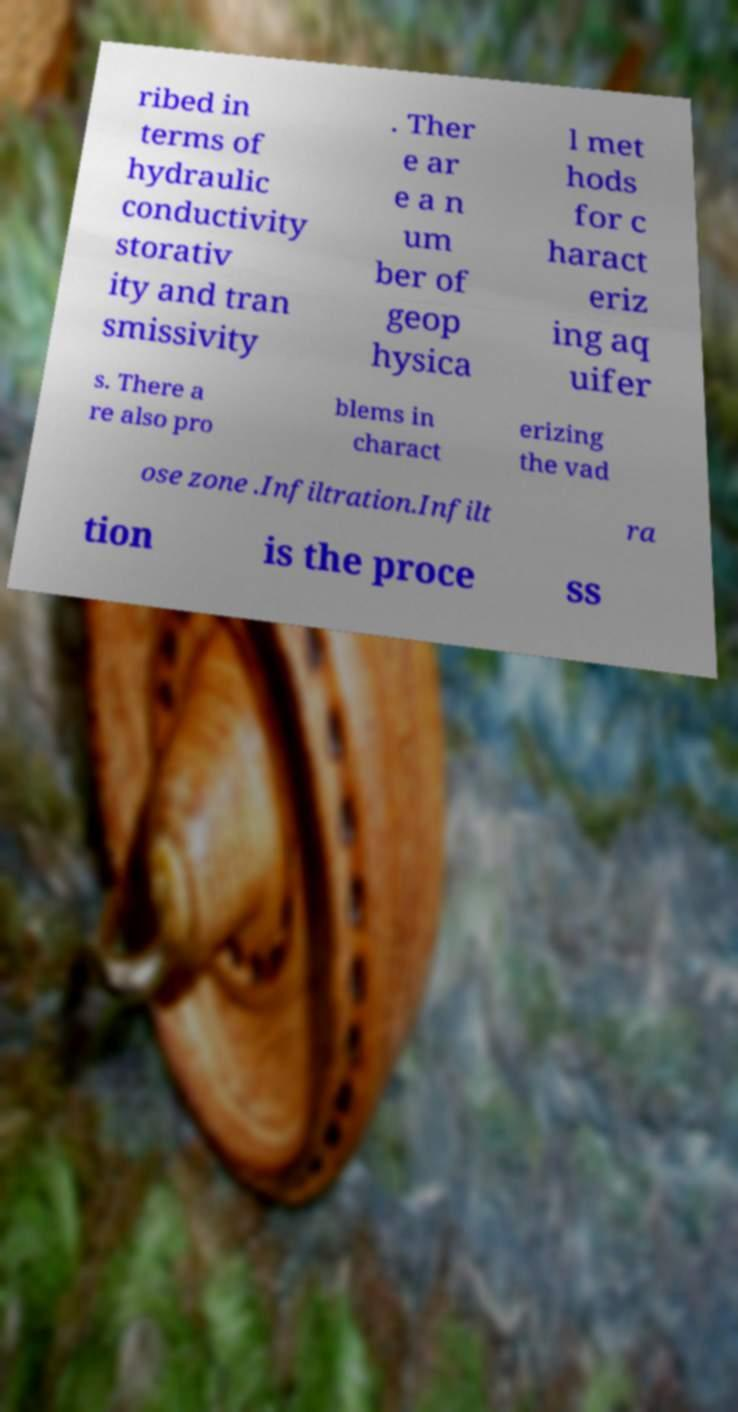Please identify and transcribe the text found in this image. ribed in terms of hydraulic conductivity storativ ity and tran smissivity . Ther e ar e a n um ber of geop hysica l met hods for c haract eriz ing aq uifer s. There a re also pro blems in charact erizing the vad ose zone .Infiltration.Infilt ra tion is the proce ss 